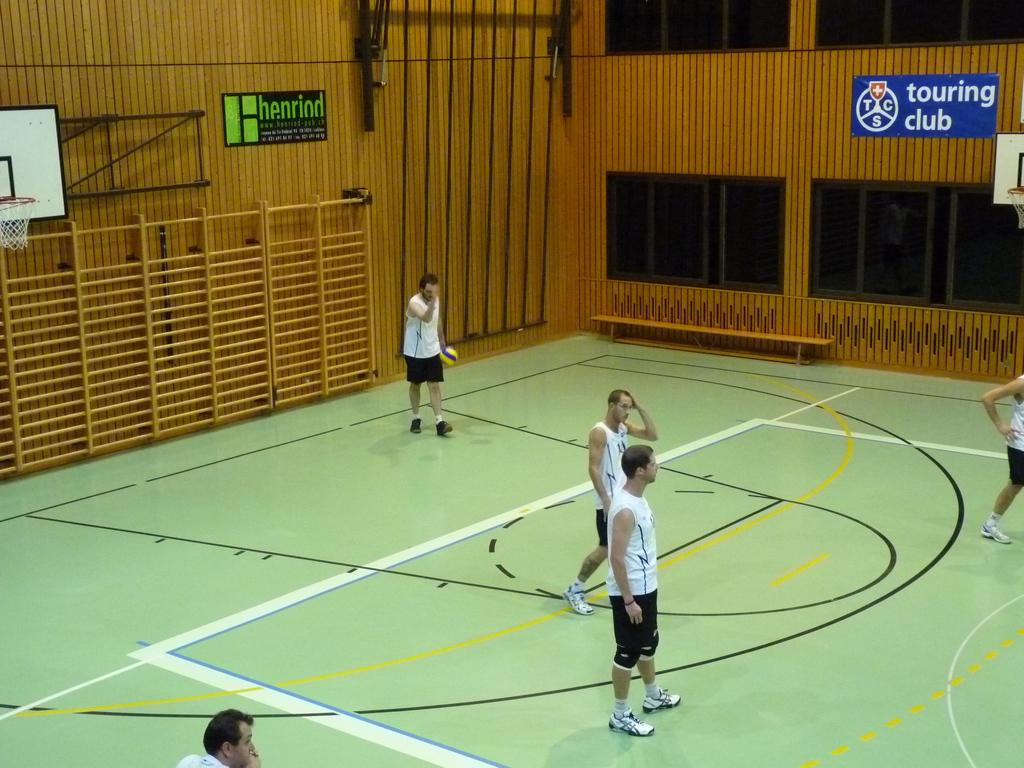<image>
Relay a brief, clear account of the picture shown. A group of men playing volleyball indoors and a sign about a touring club on a wall. 